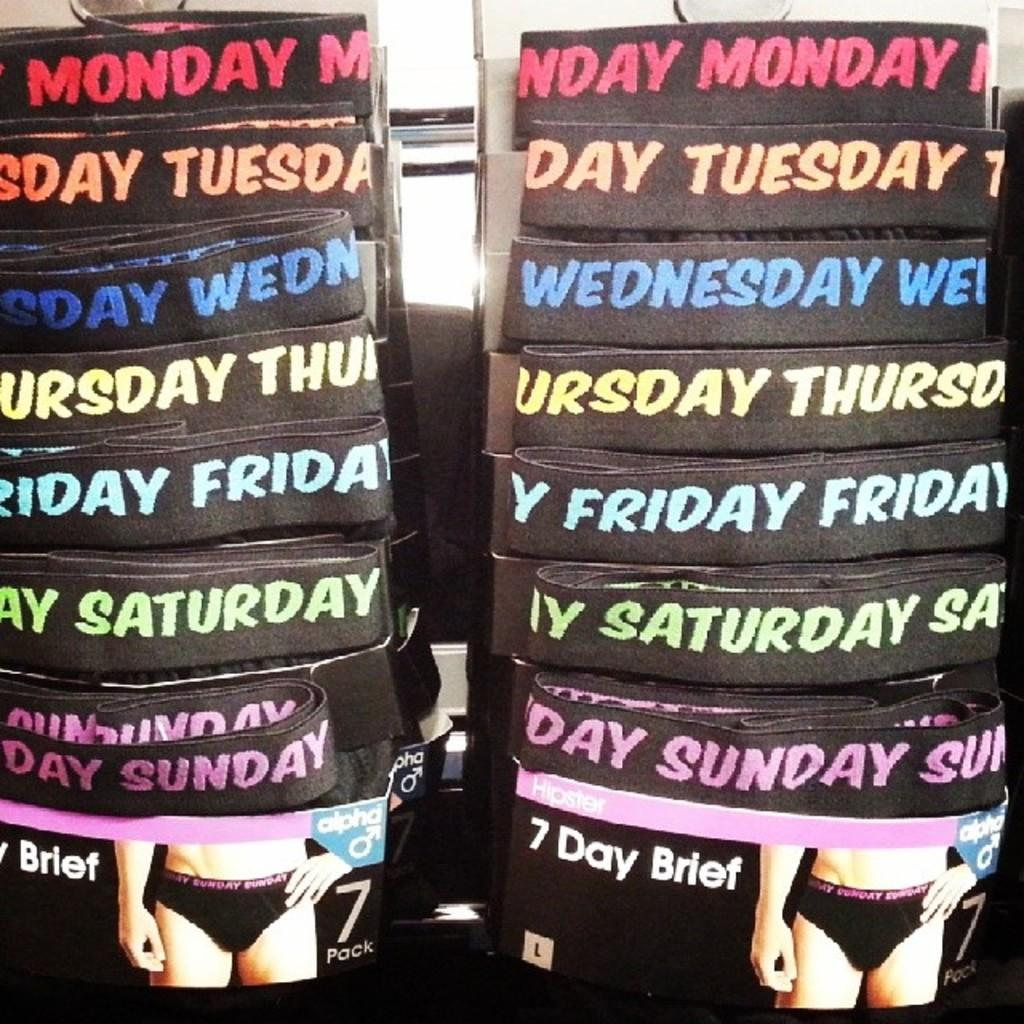What type of clothing item is present in the image? There are underpants in the image. What type of condition is the copper servant suffering from in the image? There is no copper servant or any mention of a condition in the image; it only features underpants. 